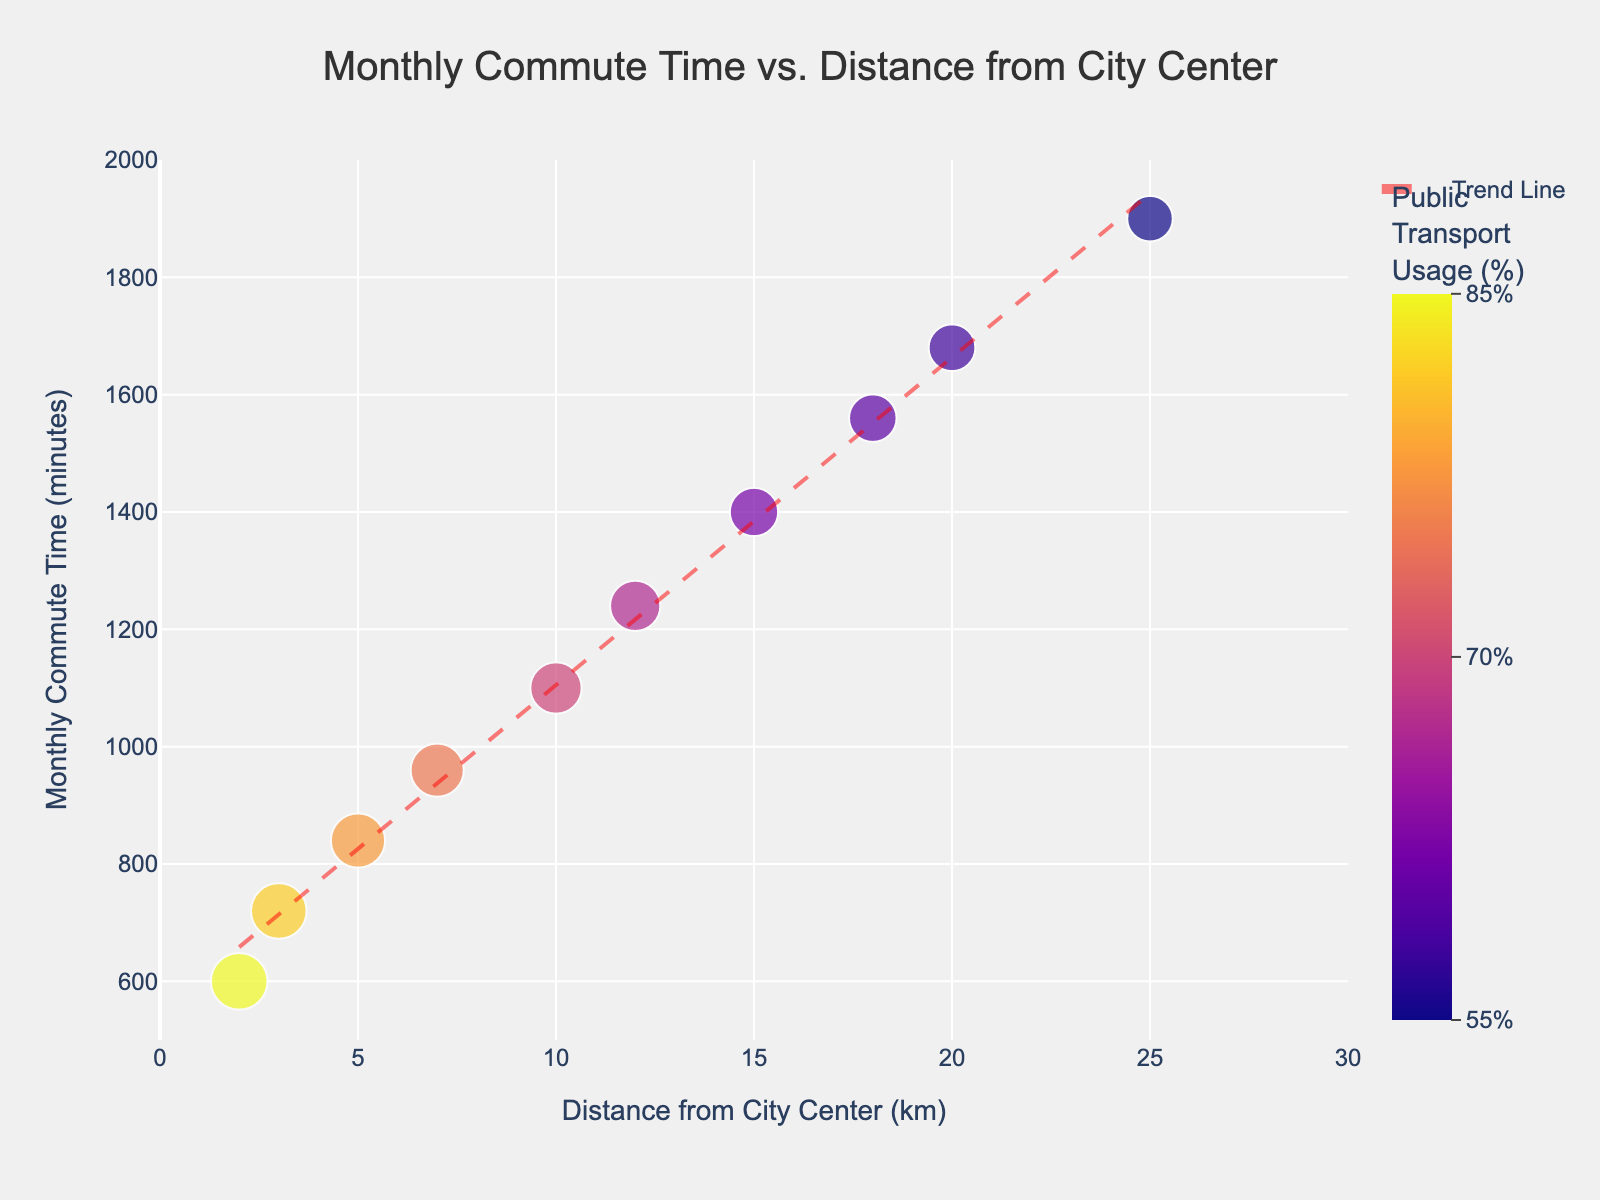What is the title of the plot? The title of the plot is typically displayed at the top center. In this figure, it reads 'Monthly Commute Time vs. Distance from City Center'.
Answer: Monthly Commute Time vs. Distance from City Center Which axis represents the distance from the city center? The x-axis represents the distance from the city center. This can be inferred from the axis label 'Distance from City Center (km)'.
Answer: x-axis How does the monthly commute time change as the distance from the city center increases? The monthly commute time tends to increase as the distance from the city center increases. This can be seen from the scatter plot's trend where upward-sloping data points indicate longer commute times for greater distances.
Answer: increases What does the size of the data points represent? The size of the data points represents the percentage of public transport usage. Larger points indicate higher usage percentages, as noted in the figure's legend.
Answer: public transport usage At what distance from the city center is the public transport usage the highest? By observing the plot, the largest point lies at a distance of 2 km from the city center, indicating the highest public transport usage at this distance.
Answer: 2 km Calculate the average monthly commute time for distances between 10 km and 20 km. To find the average, sum the monthly commute times for 10 km, 12 km, 15 km, 18 km, and 20 km. The values are 1100, 1240, 1400, 1560, and 1680 respectively, and divide by the number of data points (5). (1100 + 1240 + 1400 + 1560 + 1680) / 5 = 6980 / 5 = 1396
Answer: 1396 Compare the trend line with the individual data points. Are there any significant outliers? An outlier would be a data point that significantly deviates from the trend line. In this plot, all points closely follow the trend line, indicating no significant outliers.
Answer: no significant outliers Which distance from the city center has the lowest monthly commute time? By examining the y-axis values, the lowest monthly commute time of 600 minutes occurs at a distance of 2 km from the city center.
Answer: 2 km Which distance has the lowest percentage of public transport usage? Looking at the smallest points, the distance of 25 km from the city center shows the lowest public transport usage percentage at 55%.
Answer: 25 km What is the relationship between distance from the city center and public transport usage percentage? Observing the size and color of the points relative to the distance, it is evident that public transport usage decreases as the distance from the city center increases.
Answer: decreases 